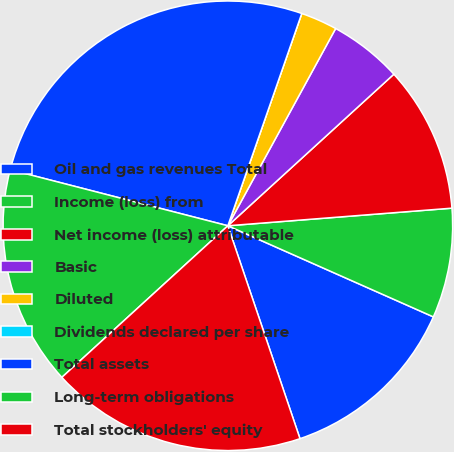Convert chart to OTSL. <chart><loc_0><loc_0><loc_500><loc_500><pie_chart><fcel>Oil and gas revenues Total<fcel>Income (loss) from<fcel>Net income (loss) attributable<fcel>Basic<fcel>Diluted<fcel>Dividends declared per share<fcel>Total assets<fcel>Long-term obligations<fcel>Total stockholders' equity<nl><fcel>13.16%<fcel>7.89%<fcel>10.53%<fcel>5.26%<fcel>2.63%<fcel>0.0%<fcel>26.32%<fcel>15.79%<fcel>18.42%<nl></chart> 